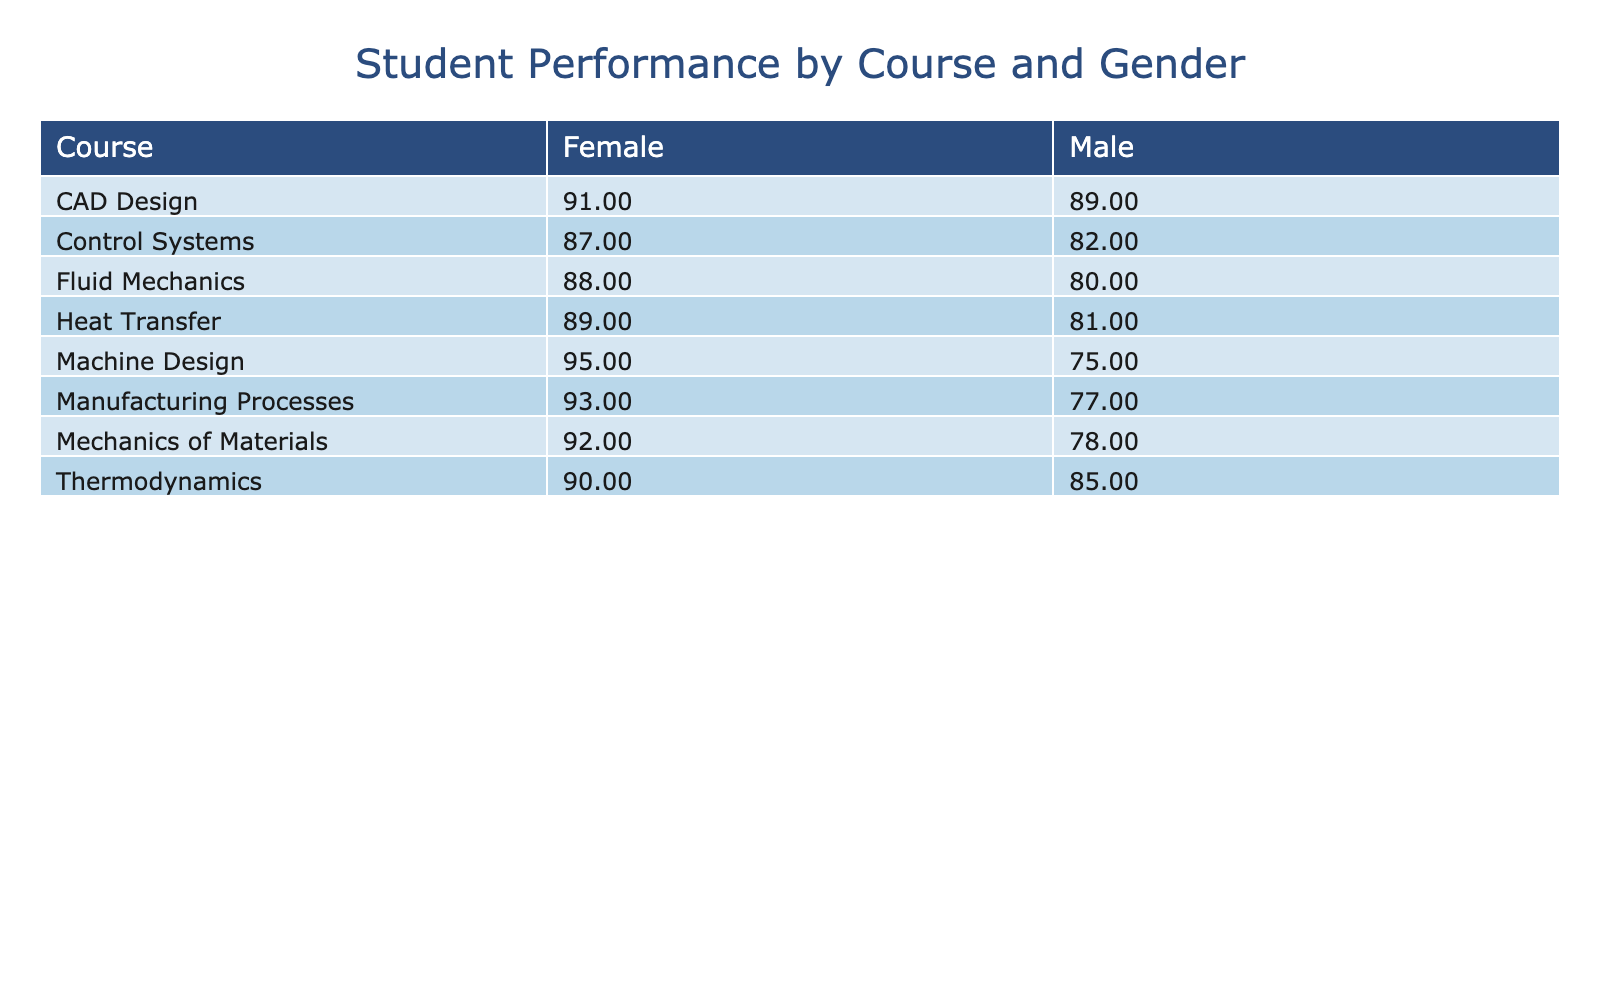What is the average student performance in Thermodynamics for males? The performance score for males in Thermodynamics is 85. Since there is only one score, the average is simply that score itself.
Answer: 85 What is the highest student performance in Fluid Mechanics? The student performance in Fluid Mechanics shows a score of 80 for males and 88 for females. The highest score is 88 for females.
Answer: 88 Is the average performance of females in Machine Design higher than that of males? For Machine Design, the female score is 95 and the male score is 75. The average performance for females (95) is higher than for males (75).
Answer: Yes What is the total student performance score for all males in Control Systems and Fluid Mechanics? The score for males in Control Systems is 82 and in Fluid Mechanics is 80. Adding these two scores gives 82 + 80 = 162.
Answer: 162 What is the difference in average student performance between males and females in Heat Transfer? In Heat Transfer, males have a score of 81 and females have a score of 89. The difference in their average performances is 89 - 81 = 8.
Answer: 8 Which course has the highest average score overall, and what is that score? By calculating the average scores for all courses, we find that Machine Design (female score 95) has the highest average score of 95.
Answer: Machine Design, 95 Are there more females than males who scored above 90 across all courses? The female scores above 90 are 90 (Thermodynamics), 92 (Mechanics of Materials), 95 (Machine Design), and 93 (Manufacturing Processes), totaling 4. The male scores above 90 are none. Thus, there are more females above 90.
Answer: Yes What is the average student performance for males across all courses? The male scores are 85 (Thermodynamics), 78 (Mechanics of Materials), 80 (Fluid Mechanics), 75 (Machine Design), 82 (Control Systems), 89 (CAD Design), 77 (Manufacturing Processes), and 81 (Heat Transfer). Summing these scores (85 + 78 + 80 + 75 + 82 + 89 + 77 + 81 =  628) gives a total of 628. There are 8 scores; hence, the average is 628 / 8 = 78.5.
Answer: 78.5 What percentage of the total performance score across all courses comes from female students? The total score for females is 90 (Thermodynamics) + 92 (Mechanics of Materials) + 88 (Fluid Mechanics) + 95 (Machine Design) + 87 (Control Systems) + 91 (CAD Design) + 93 (Manufacturing Processes) + 89 (Heat Transfer) = 715. The total score for males is previously calculated as 628. Thus, the overall total is 715 + 628 = 1343. The percentage contribution from females is (715 / 1343) * 100 ≈ 53.1%.
Answer: Approximately 53.1% 